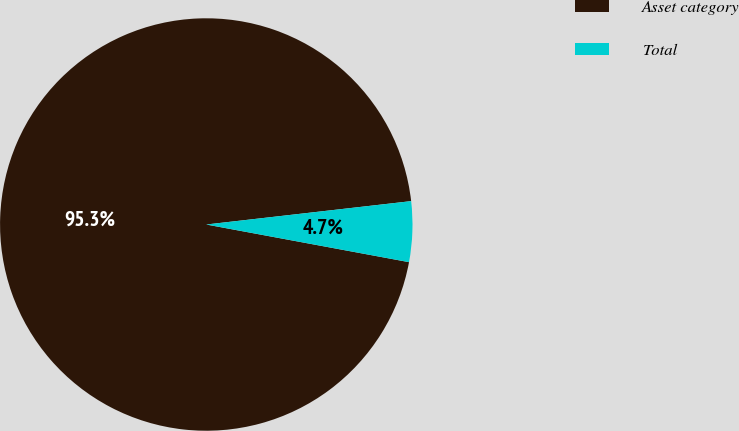Convert chart to OTSL. <chart><loc_0><loc_0><loc_500><loc_500><pie_chart><fcel>Asset category<fcel>Total<nl><fcel>95.27%<fcel>4.73%<nl></chart> 